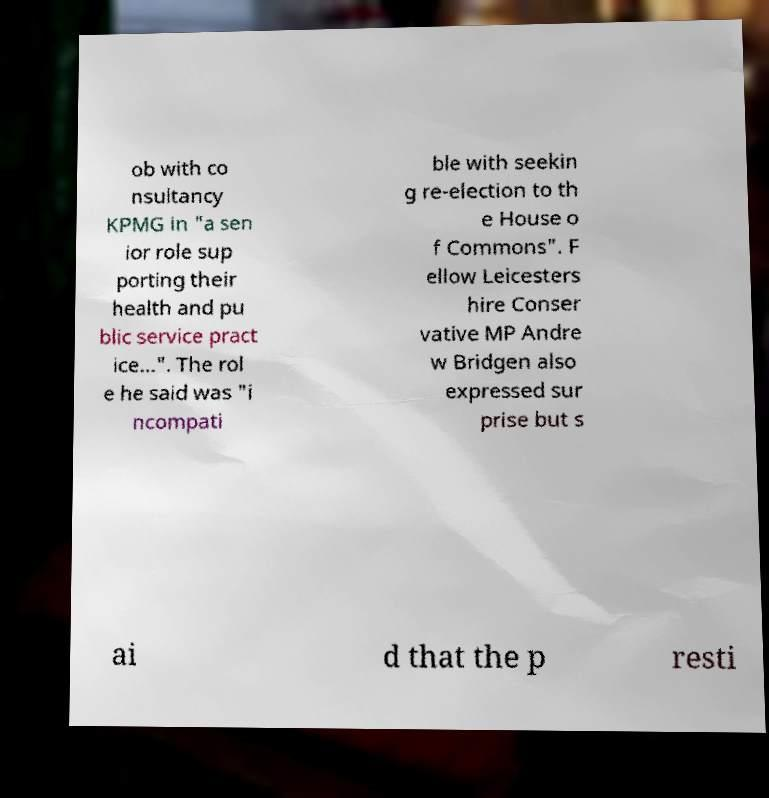Please identify and transcribe the text found in this image. ob with co nsultancy KPMG in "a sen ior role sup porting their health and pu blic service pract ice...". The rol e he said was "i ncompati ble with seekin g re-election to th e House o f Commons". F ellow Leicesters hire Conser vative MP Andre w Bridgen also expressed sur prise but s ai d that the p resti 